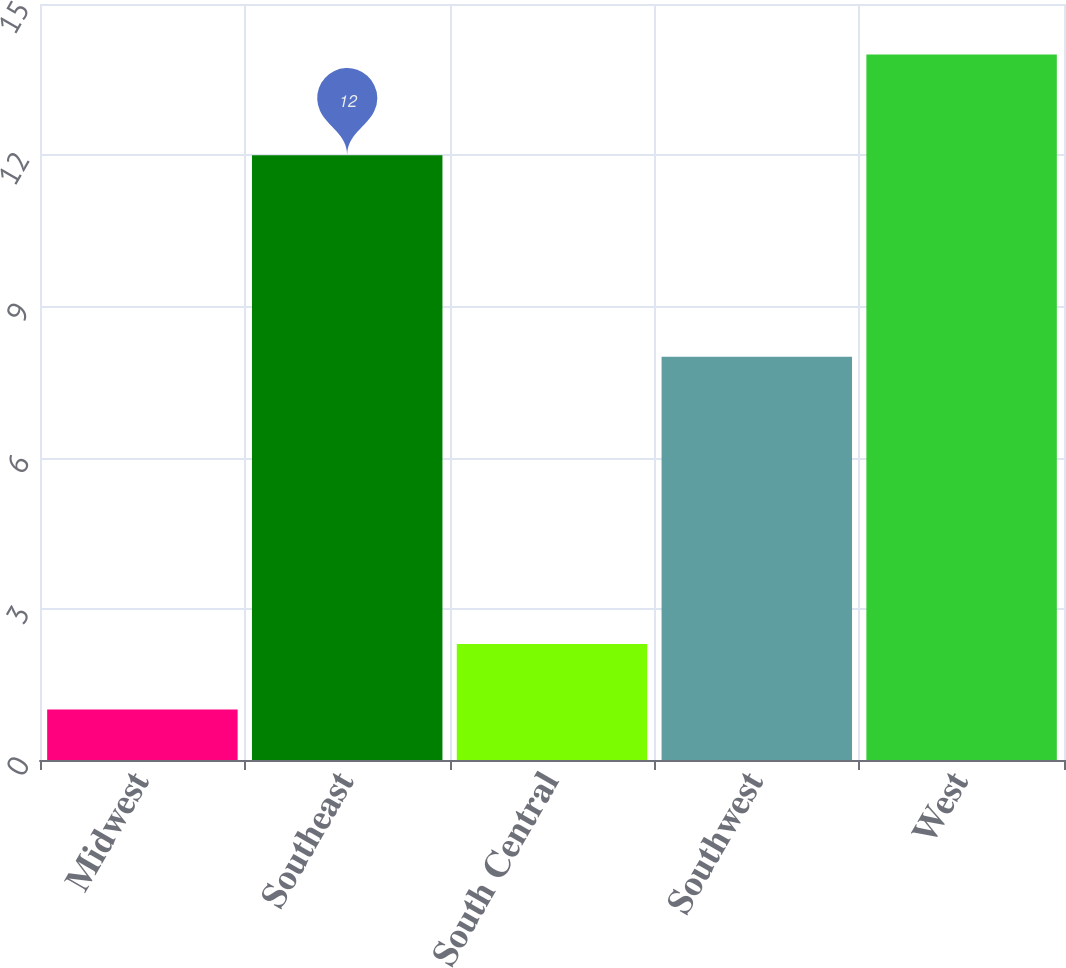<chart> <loc_0><loc_0><loc_500><loc_500><bar_chart><fcel>Midwest<fcel>Southeast<fcel>South Central<fcel>Southwest<fcel>West<nl><fcel>1<fcel>12<fcel>2.3<fcel>8<fcel>14<nl></chart> 